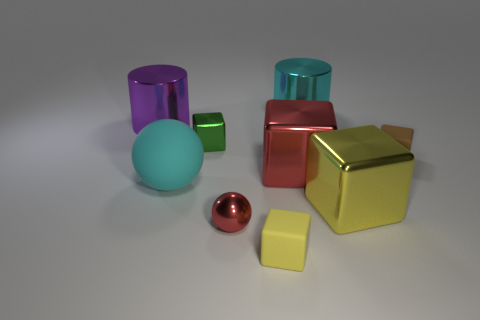Subtract all red blocks. How many blocks are left? 4 Subtract all yellow blocks. Subtract all gray spheres. How many blocks are left? 3 Subtract all balls. How many objects are left? 7 Add 5 tiny brown metallic blocks. How many tiny brown metallic blocks exist? 5 Subtract 0 yellow balls. How many objects are left? 9 Subtract all big blue shiny balls. Subtract all brown things. How many objects are left? 8 Add 5 cyan rubber things. How many cyan rubber things are left? 6 